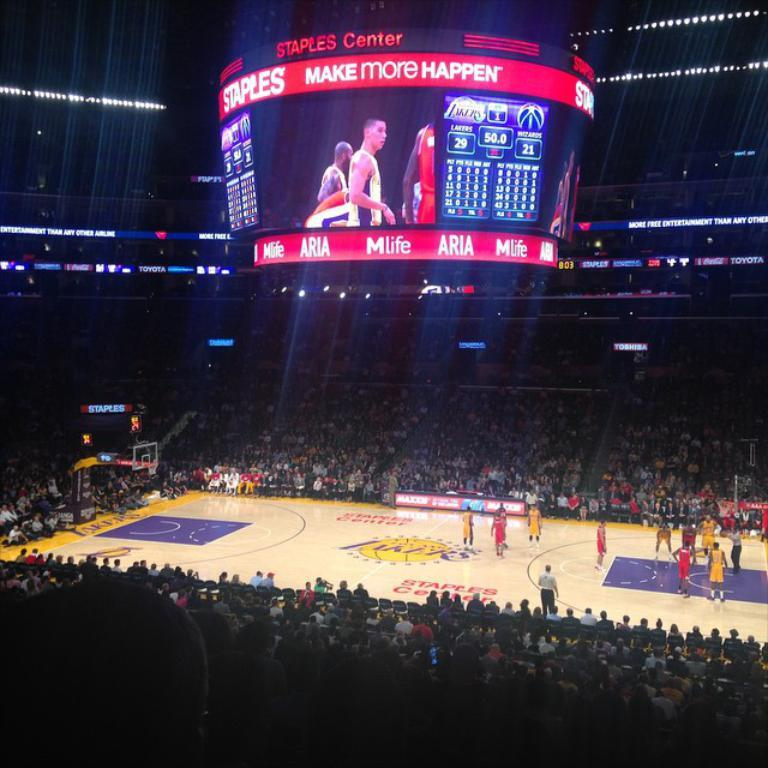<image>
Present a compact description of the photo's key features. a court for basketball and a scoreboard with Make more happen on it 